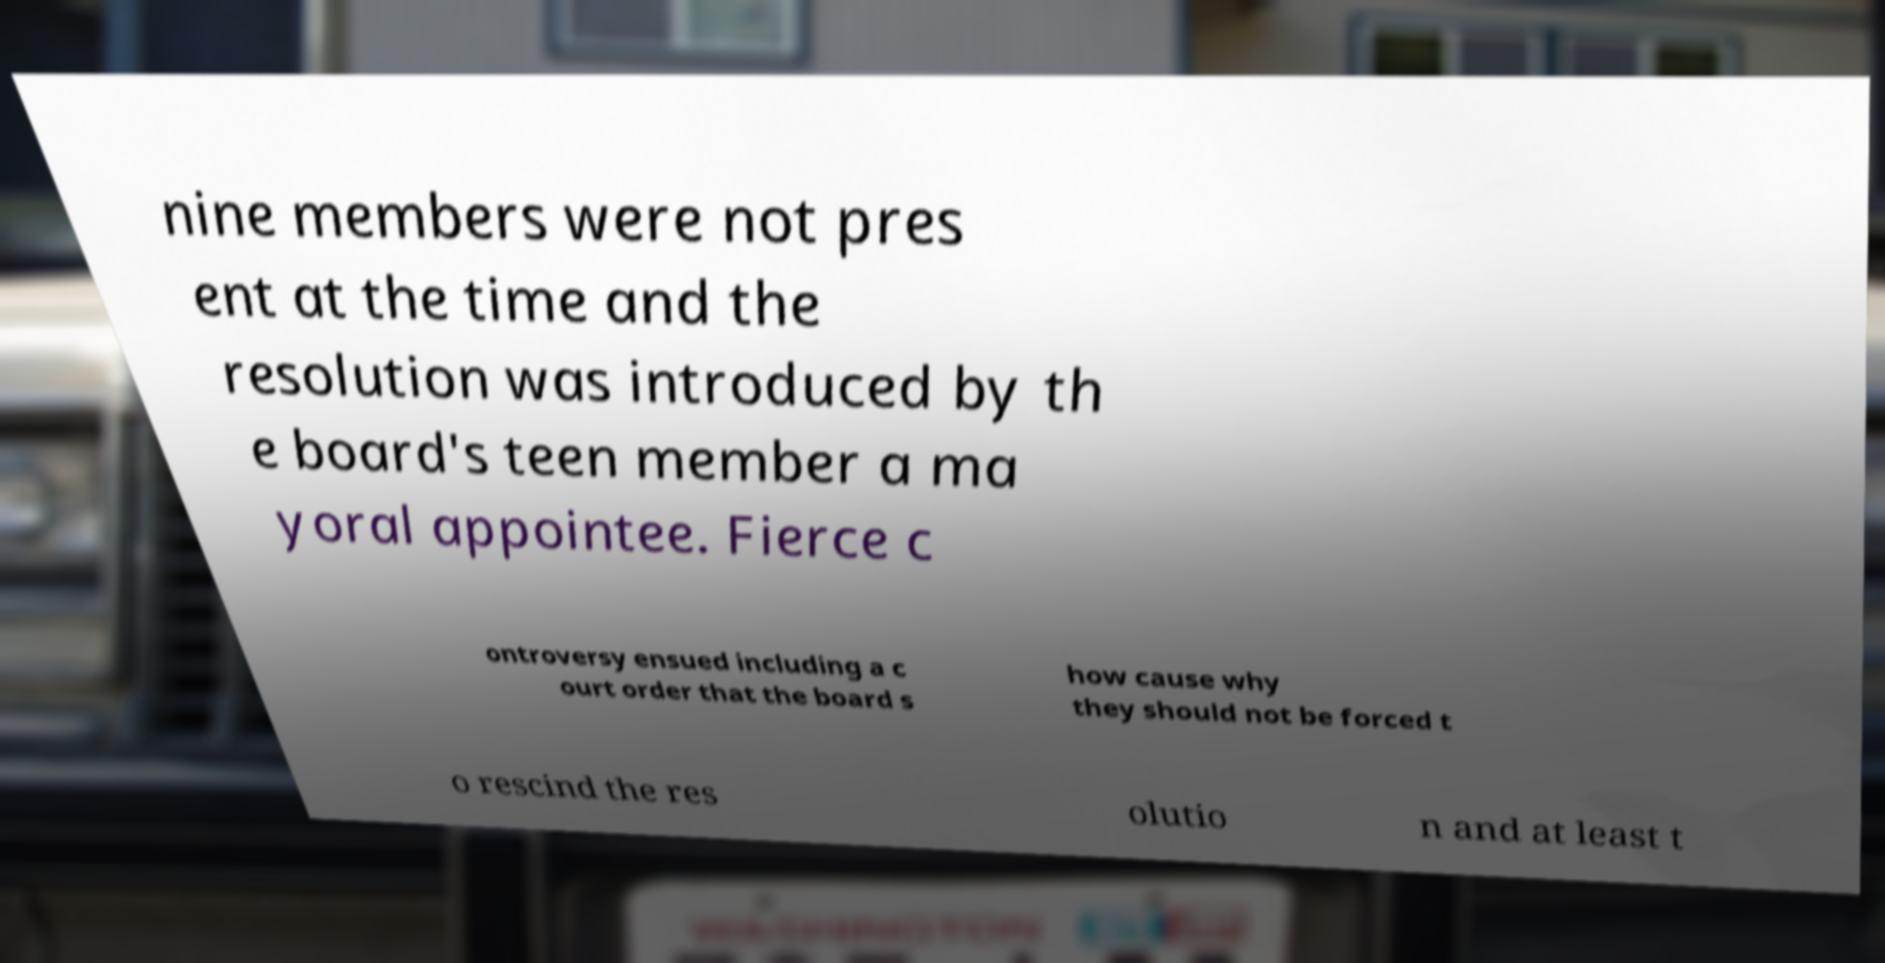Can you accurately transcribe the text from the provided image for me? nine members were not pres ent at the time and the resolution was introduced by th e board's teen member a ma yoral appointee. Fierce c ontroversy ensued including a c ourt order that the board s how cause why they should not be forced t o rescind the res olutio n and at least t 